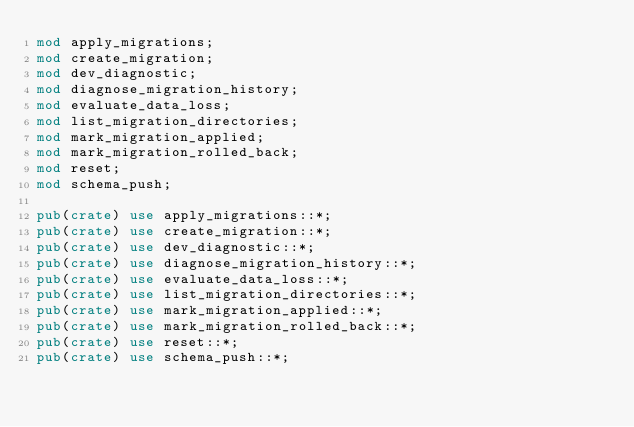Convert code to text. <code><loc_0><loc_0><loc_500><loc_500><_Rust_>mod apply_migrations;
mod create_migration;
mod dev_diagnostic;
mod diagnose_migration_history;
mod evaluate_data_loss;
mod list_migration_directories;
mod mark_migration_applied;
mod mark_migration_rolled_back;
mod reset;
mod schema_push;

pub(crate) use apply_migrations::*;
pub(crate) use create_migration::*;
pub(crate) use dev_diagnostic::*;
pub(crate) use diagnose_migration_history::*;
pub(crate) use evaluate_data_loss::*;
pub(crate) use list_migration_directories::*;
pub(crate) use mark_migration_applied::*;
pub(crate) use mark_migration_rolled_back::*;
pub(crate) use reset::*;
pub(crate) use schema_push::*;
</code> 